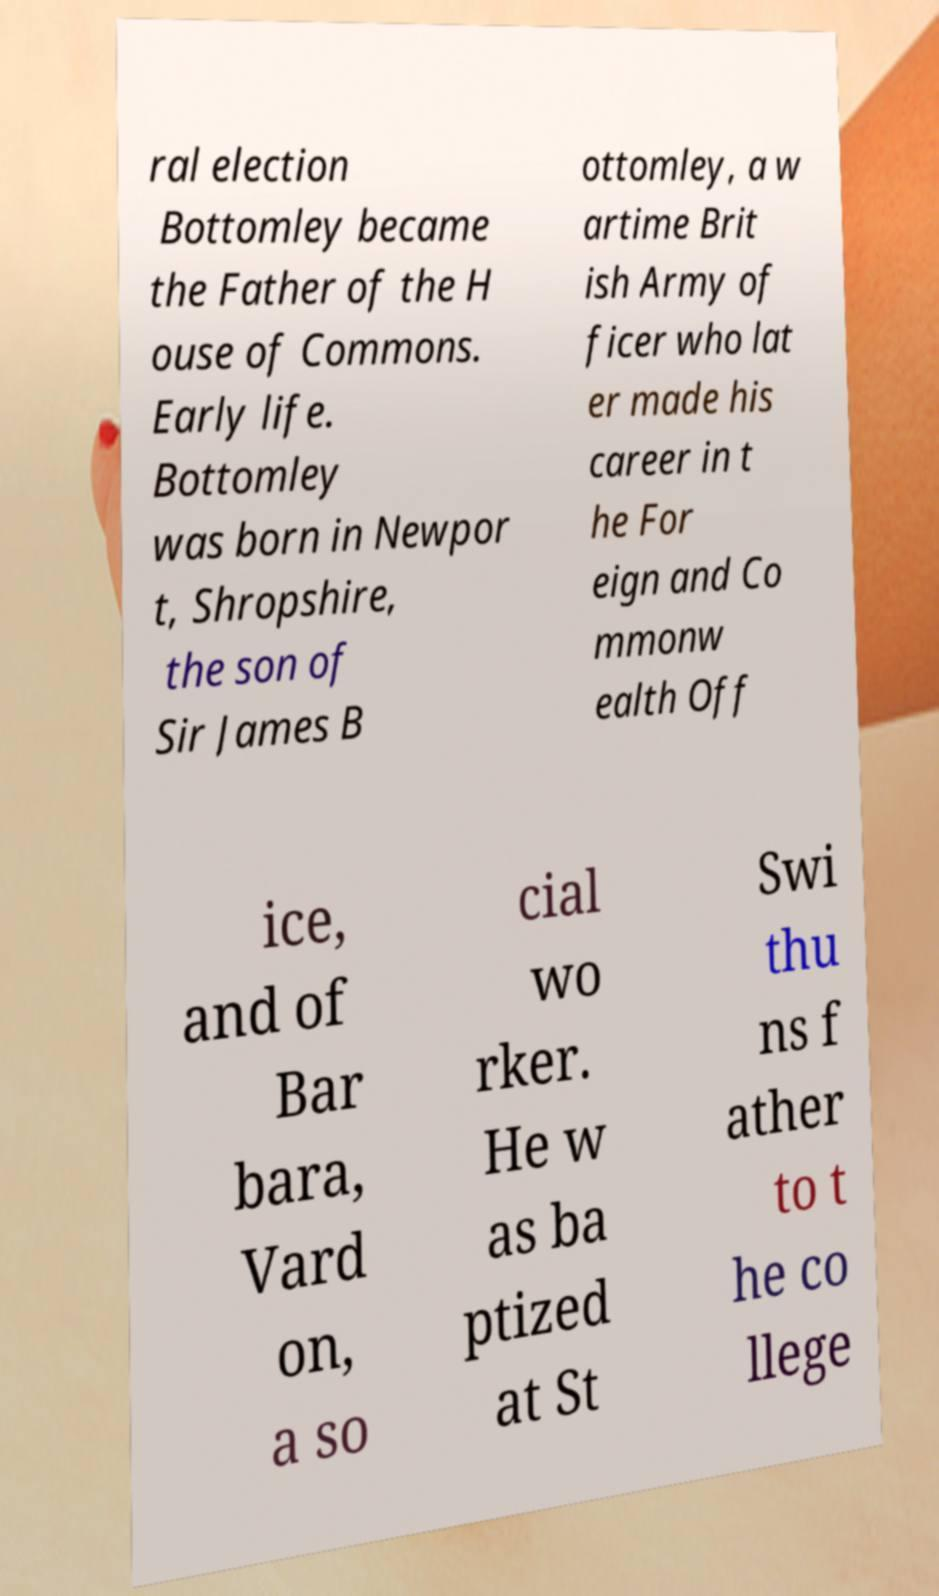Can you accurately transcribe the text from the provided image for me? ral election Bottomley became the Father of the H ouse of Commons. Early life. Bottomley was born in Newpor t, Shropshire, the son of Sir James B ottomley, a w artime Brit ish Army of ficer who lat er made his career in t he For eign and Co mmonw ealth Off ice, and of Bar bara, Vard on, a so cial wo rker. He w as ba ptized at St Swi thu ns f ather to t he co llege 